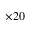<formula> <loc_0><loc_0><loc_500><loc_500>\times 2 0</formula> 